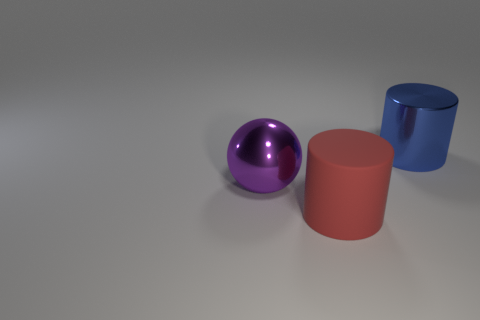Add 3 green rubber cubes. How many objects exist? 6 Subtract all cylinders. How many objects are left? 1 Add 2 cylinders. How many cylinders are left? 4 Add 1 big gray things. How many big gray things exist? 1 Subtract 0 purple cubes. How many objects are left? 3 Subtract all large metal spheres. Subtract all red things. How many objects are left? 1 